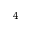Convert formula to latex. <formula><loc_0><loc_0><loc_500><loc_500>_ { 4 }</formula> 